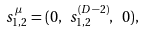Convert formula to latex. <formula><loc_0><loc_0><loc_500><loc_500>s _ { 1 , 2 } ^ { \mu } = ( 0 , \ s _ { 1 , 2 } ^ { ( D - 2 ) } , \ 0 ) ,</formula> 